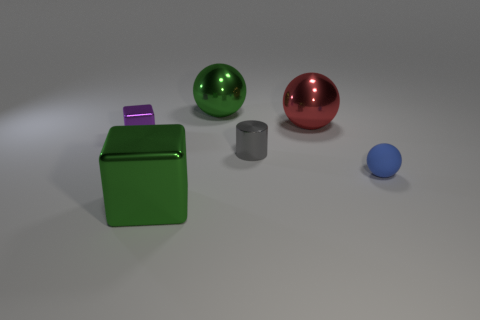The object that is behind the tiny shiny cube and right of the large green sphere is what color?
Give a very brief answer. Red. Does the tiny blue ball have the same material as the big ball in front of the green sphere?
Your answer should be very brief. No. Is the number of blue things behind the small metal block less than the number of large green metal blocks?
Provide a succinct answer. Yes. How many other things are the same shape as the tiny blue object?
Give a very brief answer. 2. Is there any other thing of the same color as the big block?
Ensure brevity in your answer.  Yes. There is a large cube; is it the same color as the shiny ball that is behind the large red metallic object?
Offer a very short reply. Yes. How many other objects are there of the same size as the green shiny cube?
Offer a very short reply. 2. The ball that is the same color as the large cube is what size?
Offer a very short reply. Large. How many cubes are purple metallic things or tiny gray things?
Give a very brief answer. 1. There is a metal thing right of the small gray object; does it have the same shape as the tiny rubber thing?
Offer a very short reply. Yes. 